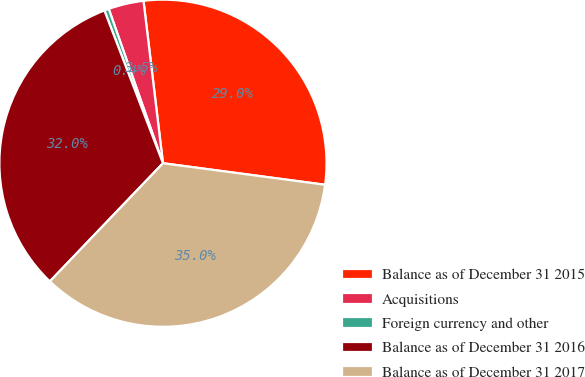Convert chart to OTSL. <chart><loc_0><loc_0><loc_500><loc_500><pie_chart><fcel>Balance as of December 31 2015<fcel>Acquisitions<fcel>Foreign currency and other<fcel>Balance as of December 31 2016<fcel>Balance as of December 31 2017<nl><fcel>29.0%<fcel>3.48%<fcel>0.45%<fcel>32.02%<fcel>35.05%<nl></chart> 